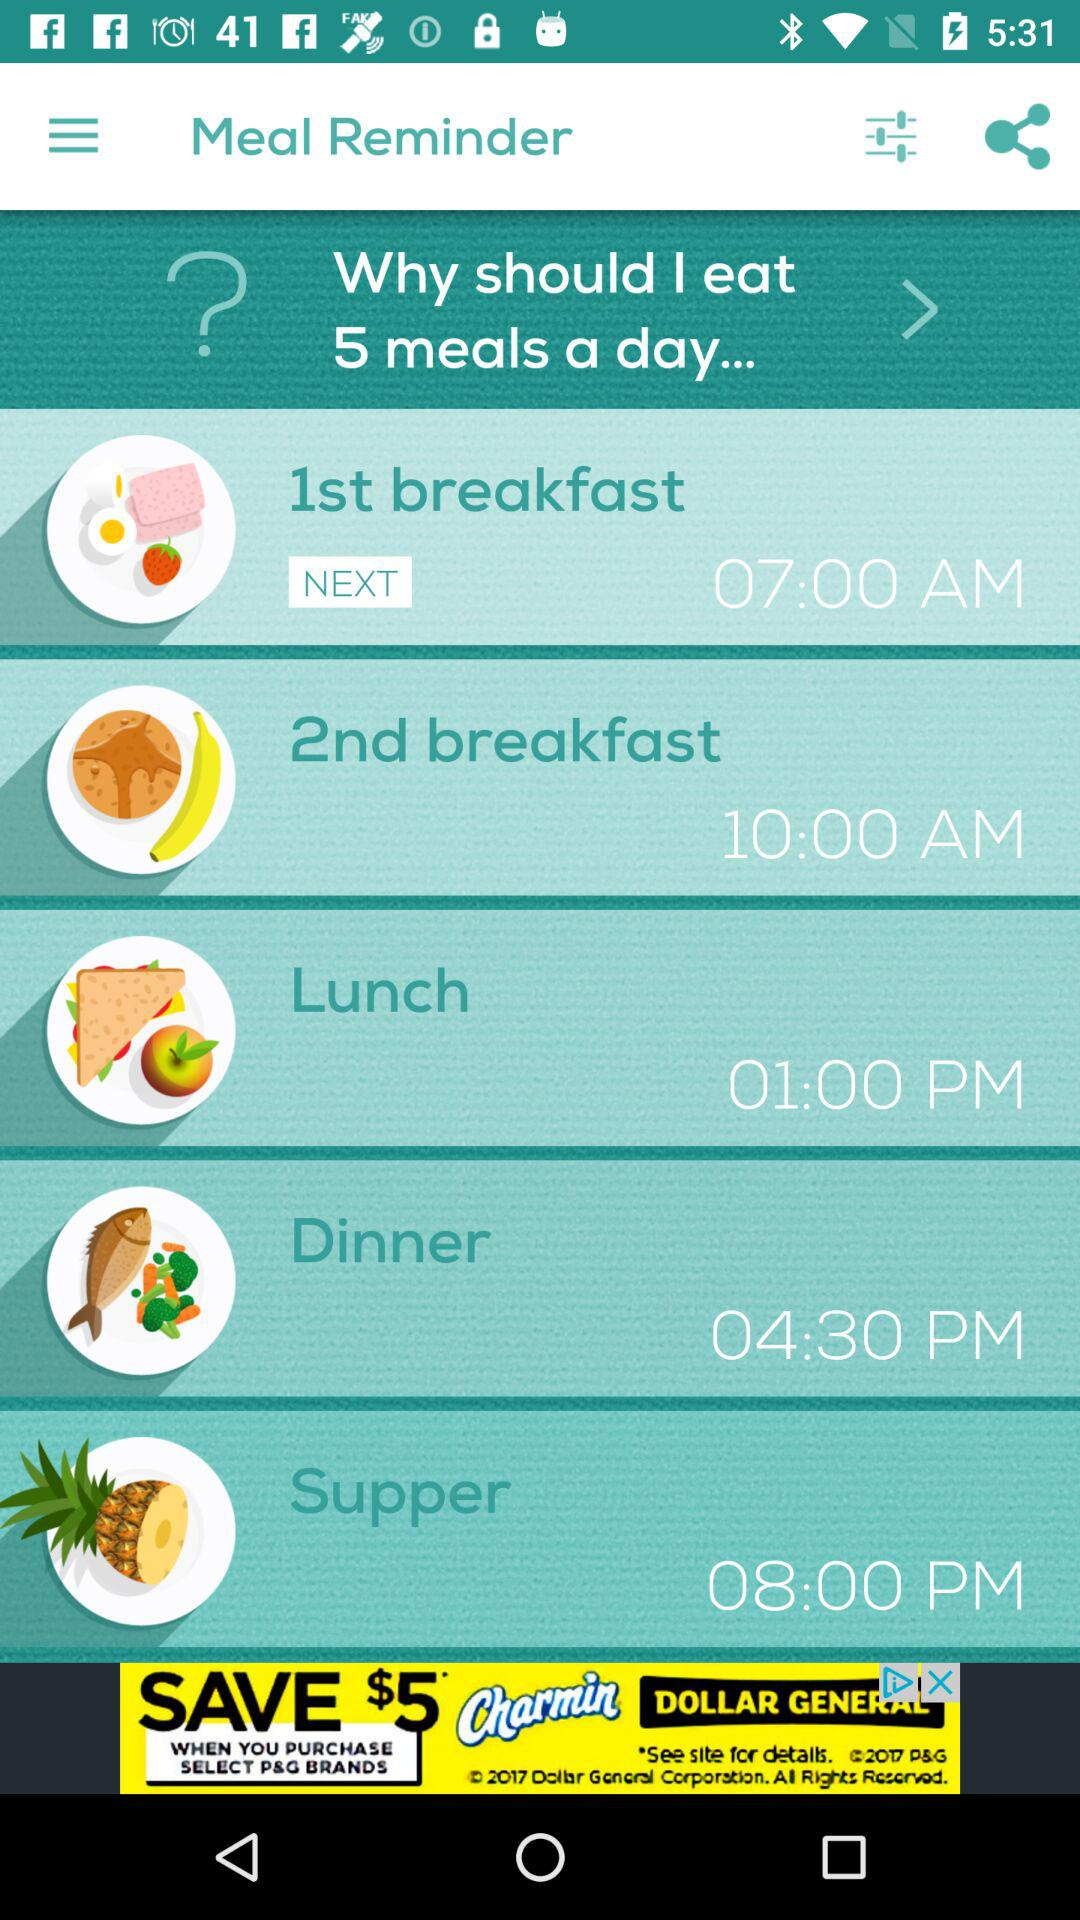What is the name of the application? The name of the application is "Meal Reminder". 